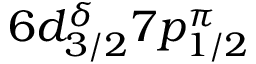Convert formula to latex. <formula><loc_0><loc_0><loc_500><loc_500>6 d _ { 3 / 2 } ^ { \delta } 7 p _ { 1 / 2 } ^ { \pi }</formula> 